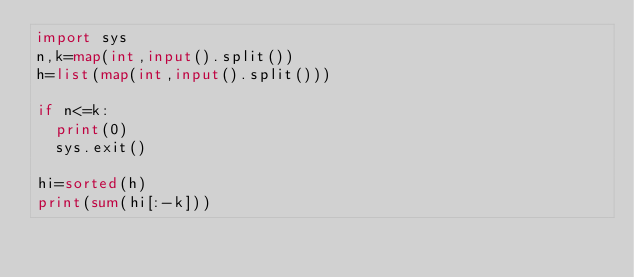<code> <loc_0><loc_0><loc_500><loc_500><_Python_>import sys
n,k=map(int,input().split())
h=list(map(int,input().split()))

if n<=k:
  print(0)
  sys.exit()

hi=sorted(h)
print(sum(hi[:-k]))
</code> 